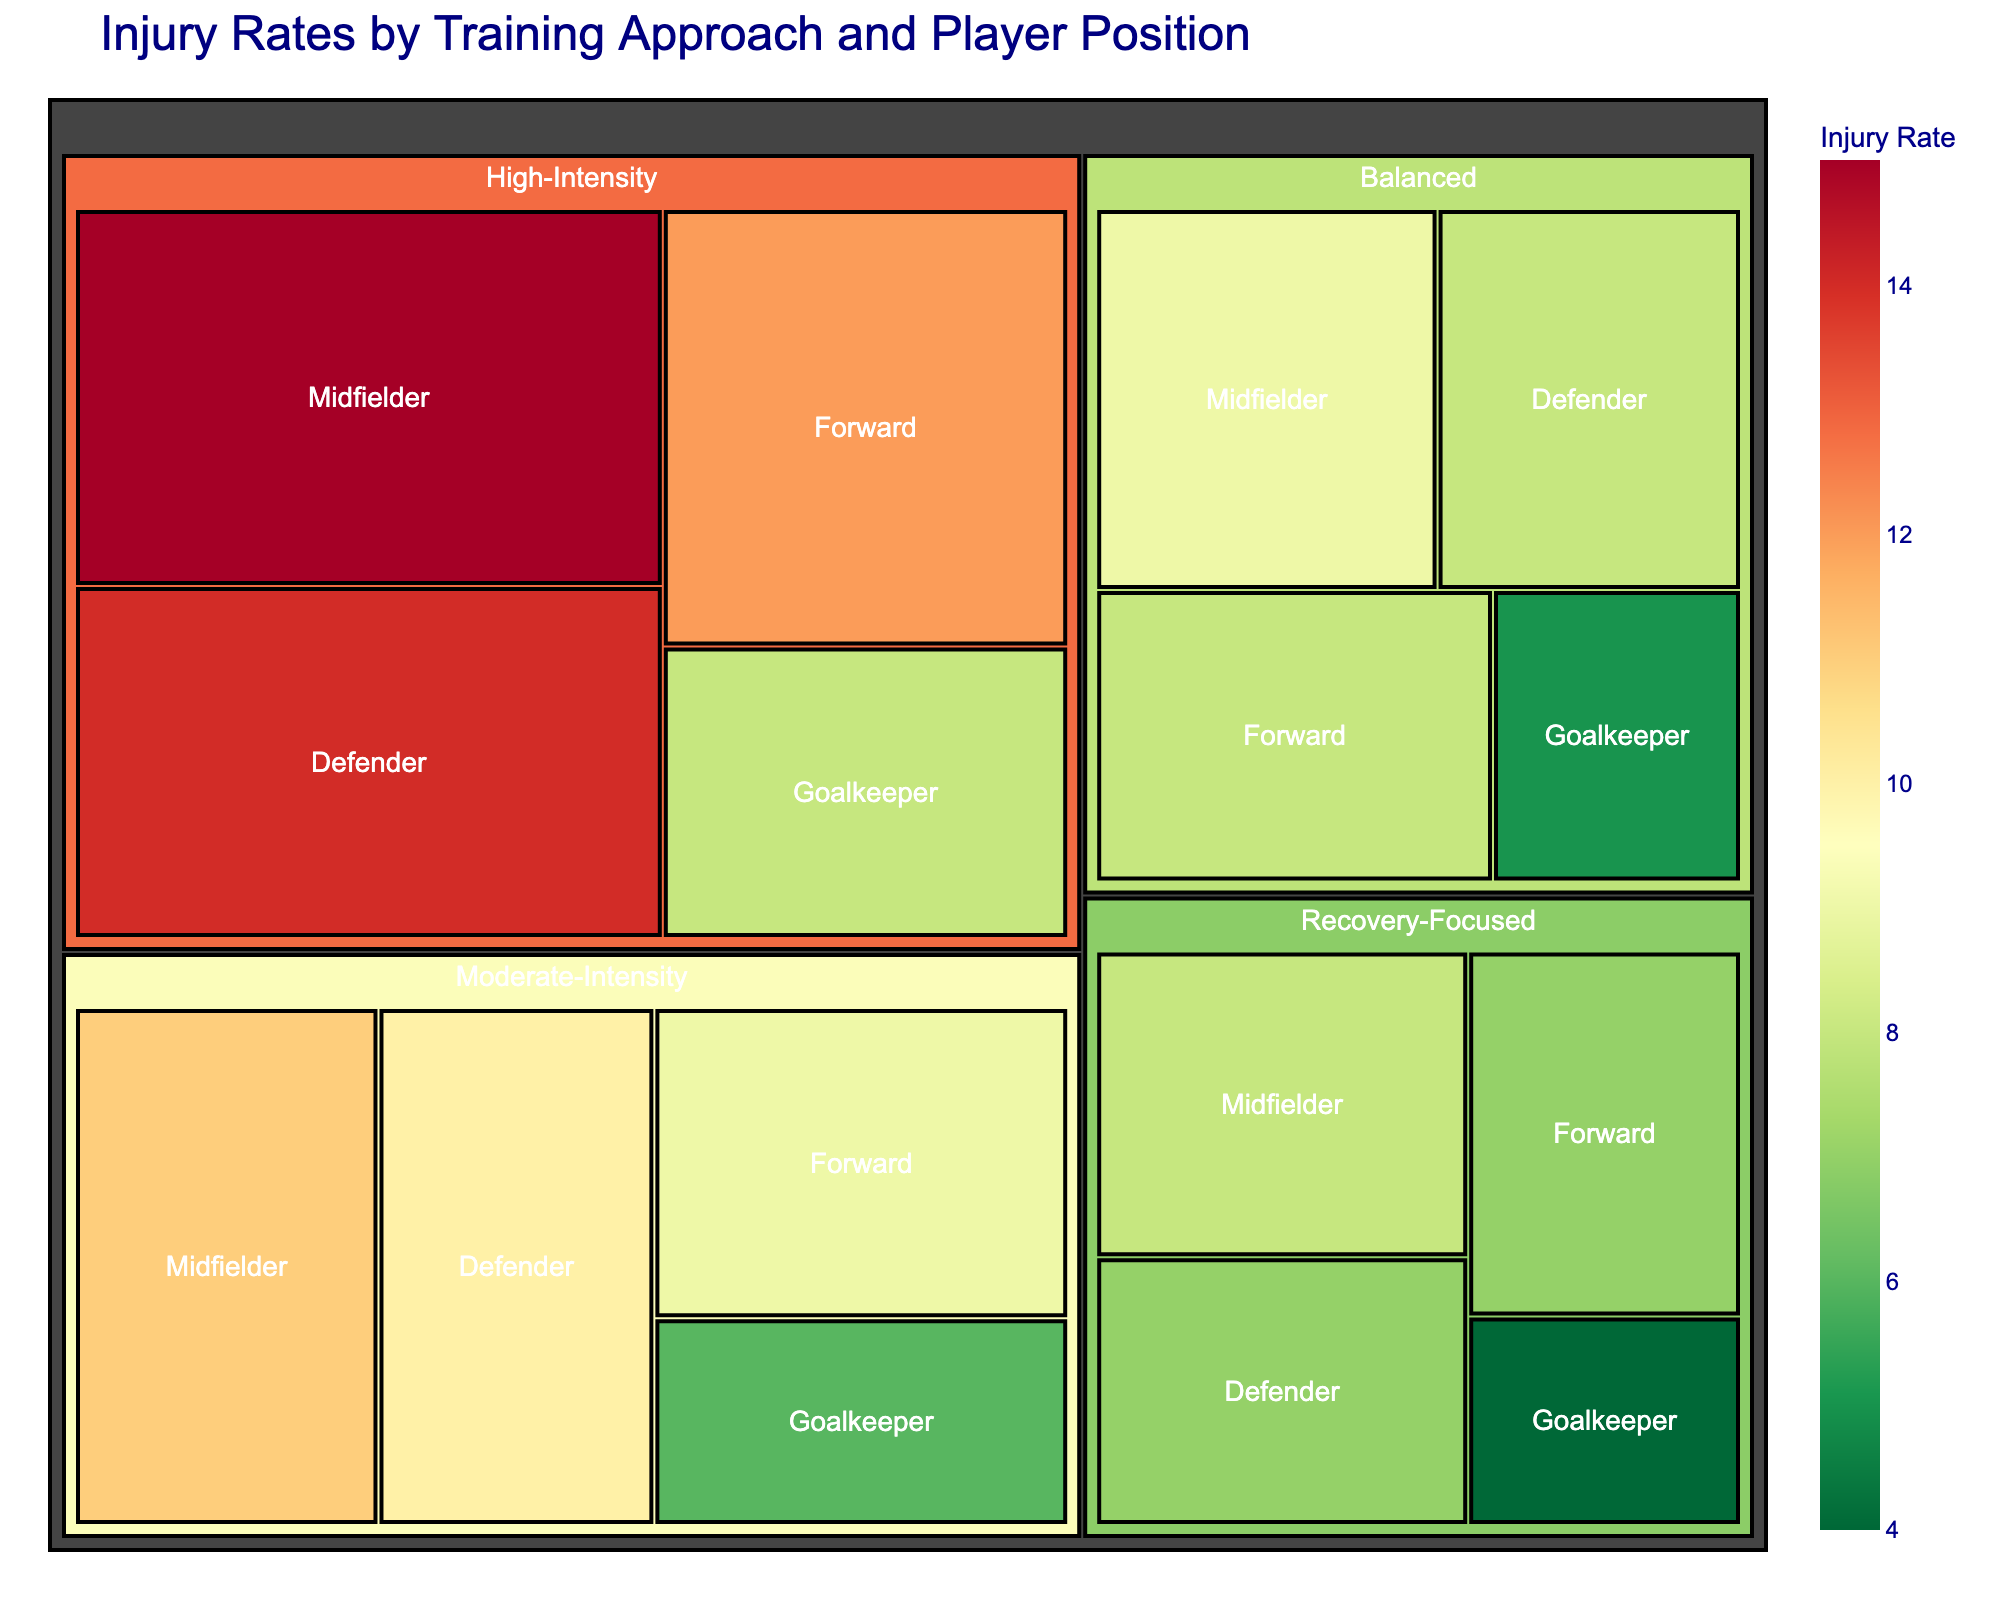What's the title of the figure? The title of the figure can be found at the top of the plot in larger and bold text, which is standard for most figures to provide context.
Answer: Injury Rates by Training Approach and Player Position Which training approach has the highest overall injury rate? The treemap visually highlights the intensity of injury rates using colors, from red (high) to green (low). By identifying the largest, darkest red segments, it is clear which training approach stands out for high injury rates.
Answer: High-Intensity What is the injury rate for Goalkeepers under the Recovery-Focused training approach? Locate the Recovery-Focused section in the treemap and then look for the Goalkeeper segment within it. The injury rate value is displayed inside the segment or will appear on hover.
Answer: 4 Compare the injury rates for Midfielders between the High-Intensity and Balanced training approaches. Which one is higher? Identify the High-Intensity and Balanced sections; then, find the Midfielder injury rates within each. The High-Intensity injury rate for Midfielders is 15, while for Balanced it is 9. Comparing these values shows which is higher.
Answer: High-Intensity What is the total injury rate for all positions under the Moderate-Intensity training approach? Add the injury rates for all player positions within the Moderate-Intensity section: Forward (9), Midfielder (11), Defender (10), and Goalkeeper (6). 9 + 11 + 10 + 6 = 36.
Answer: 36 Which player position under the High-Intensity training approach has the lowest injury rate? Within the High-Intensity section, compare the injury rates for all player positions. The forward (12), midfielder (15), defender (14), and goalkeeper (8). The lowest is Goalkeeper.
Answer: Goalkeeper How does the injury rate for Defenders under the Balanced approach compare to the Recovery-Focused approach? Check the Balanced section for Defenders (8) and the Recovery-Focused section for Defenders (7). Comparing these two values shows which is higher.
Answer: Balanced has a higher injury rate What's the average injury rate for Forwards across all training approaches? Sum the injury rates for Forwards across different training approaches and then divide by the number of training approaches. (12+9+7+8)/4 = 36/4.
Answer: 9 Which training approach has the smallest variation in injury rates between different player positions? Evaluate the differences between the highest and lowest injury rates within each training approach. Recovery-Focused: 4 to 8 (4), Balanced: 5 to 9 (4), High-Intensity: 8 to 15 (7), Moderate-Intensity: 6 to 11 (5). Recovery-Focused and Balanced both show the smallest variation (4).
Answer: Recovery-Focused or Balanced Which player position tends to have consistently lower injury rates across different training approaches? Compare the injury rates of each player position across all training approaches. Goalkeepers generally have the lowest injury rates: High-Intensity (8), Moderate-Intensity (6), Recovery-Focused (4), Balanced (5).
Answer: Goalkeeper 